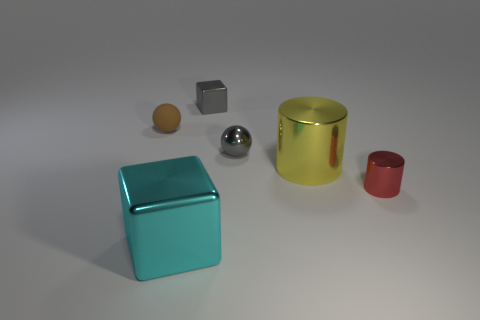Does the metallic block to the right of the big shiny block have the same color as the small sphere to the right of the tiny shiny block?
Your response must be concise. Yes. Are there any rubber spheres to the left of the metallic sphere?
Ensure brevity in your answer.  Yes. What material is the object that is both on the left side of the small metal block and behind the big cyan thing?
Make the answer very short. Rubber. Does the tiny cylinder on the right side of the gray metallic cube have the same material as the cyan object?
Your answer should be compact. Yes. What material is the brown object?
Offer a terse response. Rubber. There is a sphere that is behind the tiny metal ball; how big is it?
Provide a short and direct response. Small. Is there anything else that is the same color as the shiny sphere?
Provide a succinct answer. Yes. There is a shiny cube behind the thing that is on the left side of the cyan thing; is there a big metallic block that is right of it?
Your answer should be very brief. No. Do the cube that is behind the red metallic thing and the metallic ball have the same color?
Offer a terse response. Yes. How many cylinders are small shiny objects or brown shiny objects?
Keep it short and to the point. 1. 